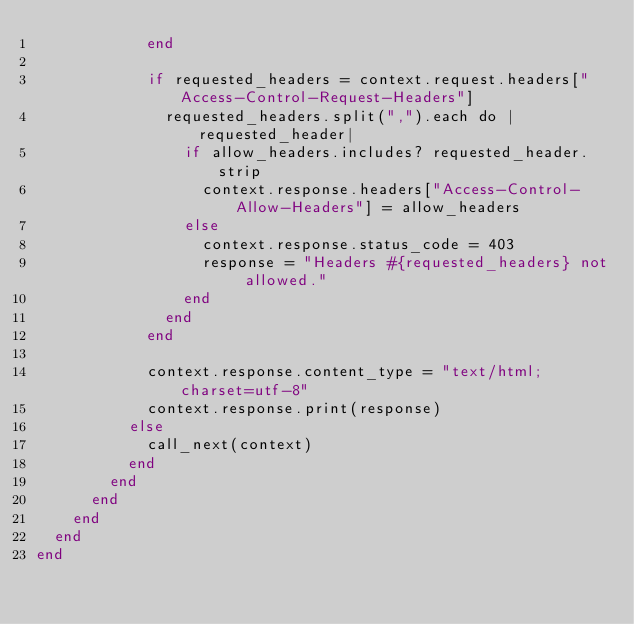Convert code to text. <code><loc_0><loc_0><loc_500><loc_500><_Crystal_>            end

            if requested_headers = context.request.headers["Access-Control-Request-Headers"]
              requested_headers.split(",").each do |requested_header|
                if allow_headers.includes? requested_header.strip
                  context.response.headers["Access-Control-Allow-Headers"] = allow_headers
                else
                  context.response.status_code = 403
                  response = "Headers #{requested_headers} not allowed."
                end
              end
            end

            context.response.content_type = "text/html; charset=utf-8"
            context.response.print(response)
          else
            call_next(context)
          end
        end
      end
    end
  end
end
</code> 